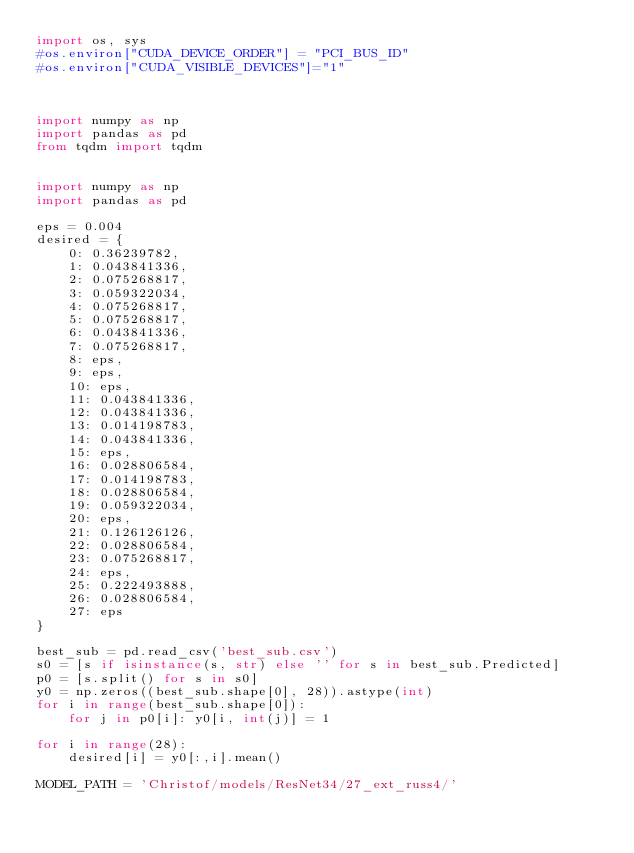Convert code to text. <code><loc_0><loc_0><loc_500><loc_500><_Python_>import os, sys
#os.environ["CUDA_DEVICE_ORDER"] = "PCI_BUS_ID"
#os.environ["CUDA_VISIBLE_DEVICES"]="1"



import numpy as np
import pandas as pd
from tqdm import tqdm


import numpy as np
import pandas as pd

eps = 0.004
desired = {
    0: 0.36239782,
    1: 0.043841336,
    2: 0.075268817,
    3: 0.059322034,
    4: 0.075268817,
    5: 0.075268817,
    6: 0.043841336,
    7: 0.075268817,
    8: eps,
    9: eps,
    10: eps,
    11: 0.043841336,
    12: 0.043841336,
    13: 0.014198783,
    14: 0.043841336,
    15: eps,
    16: 0.028806584,
    17: 0.014198783,
    18: 0.028806584,
    19: 0.059322034,
    20: eps,
    21: 0.126126126,
    22: 0.028806584,
    23: 0.075268817,
    24: eps,
    25: 0.222493888,
    26: 0.028806584,
    27: eps
}

best_sub = pd.read_csv('best_sub.csv')
s0 = [s if isinstance(s, str) else '' for s in best_sub.Predicted]
p0 = [s.split() for s in s0]
y0 = np.zeros((best_sub.shape[0], 28)).astype(int)
for i in range(best_sub.shape[0]):
    for j in p0[i]: y0[i, int(j)] = 1

for i in range(28):
    desired[i] = y0[:,i].mean()

MODEL_PATH = 'Christof/models/ResNet34/27_ext_russ4/'
</code> 